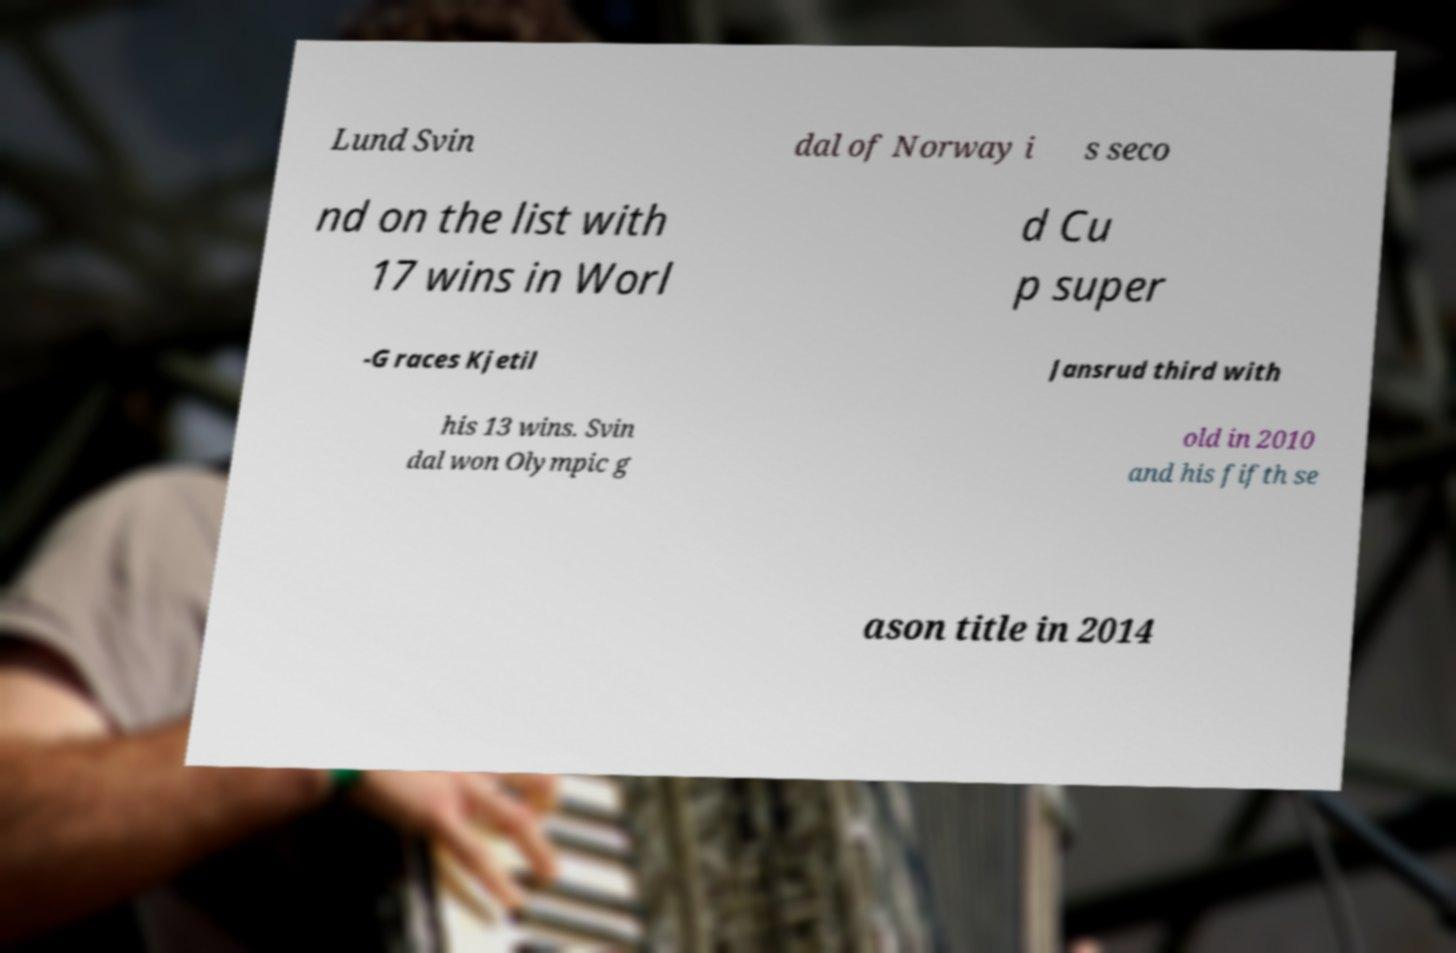I need the written content from this picture converted into text. Can you do that? Lund Svin dal of Norway i s seco nd on the list with 17 wins in Worl d Cu p super -G races Kjetil Jansrud third with his 13 wins. Svin dal won Olympic g old in 2010 and his fifth se ason title in 2014 